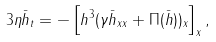<formula> <loc_0><loc_0><loc_500><loc_500>3 \eta \bar { h } _ { t } = - \left [ h ^ { 3 } ( \gamma \bar { h } _ { x x } + \Pi ( \bar { h } ) ) _ { x } \right ] _ { x } ,</formula> 